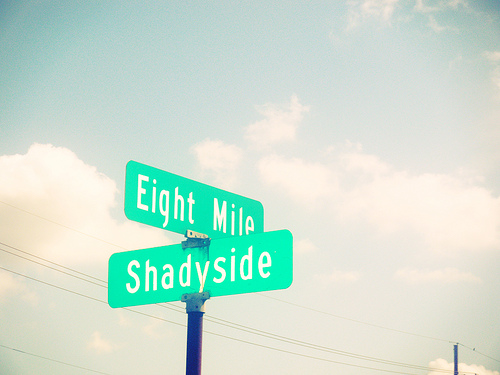Extract all visible text content from this image. Eight Mile Shadyside 